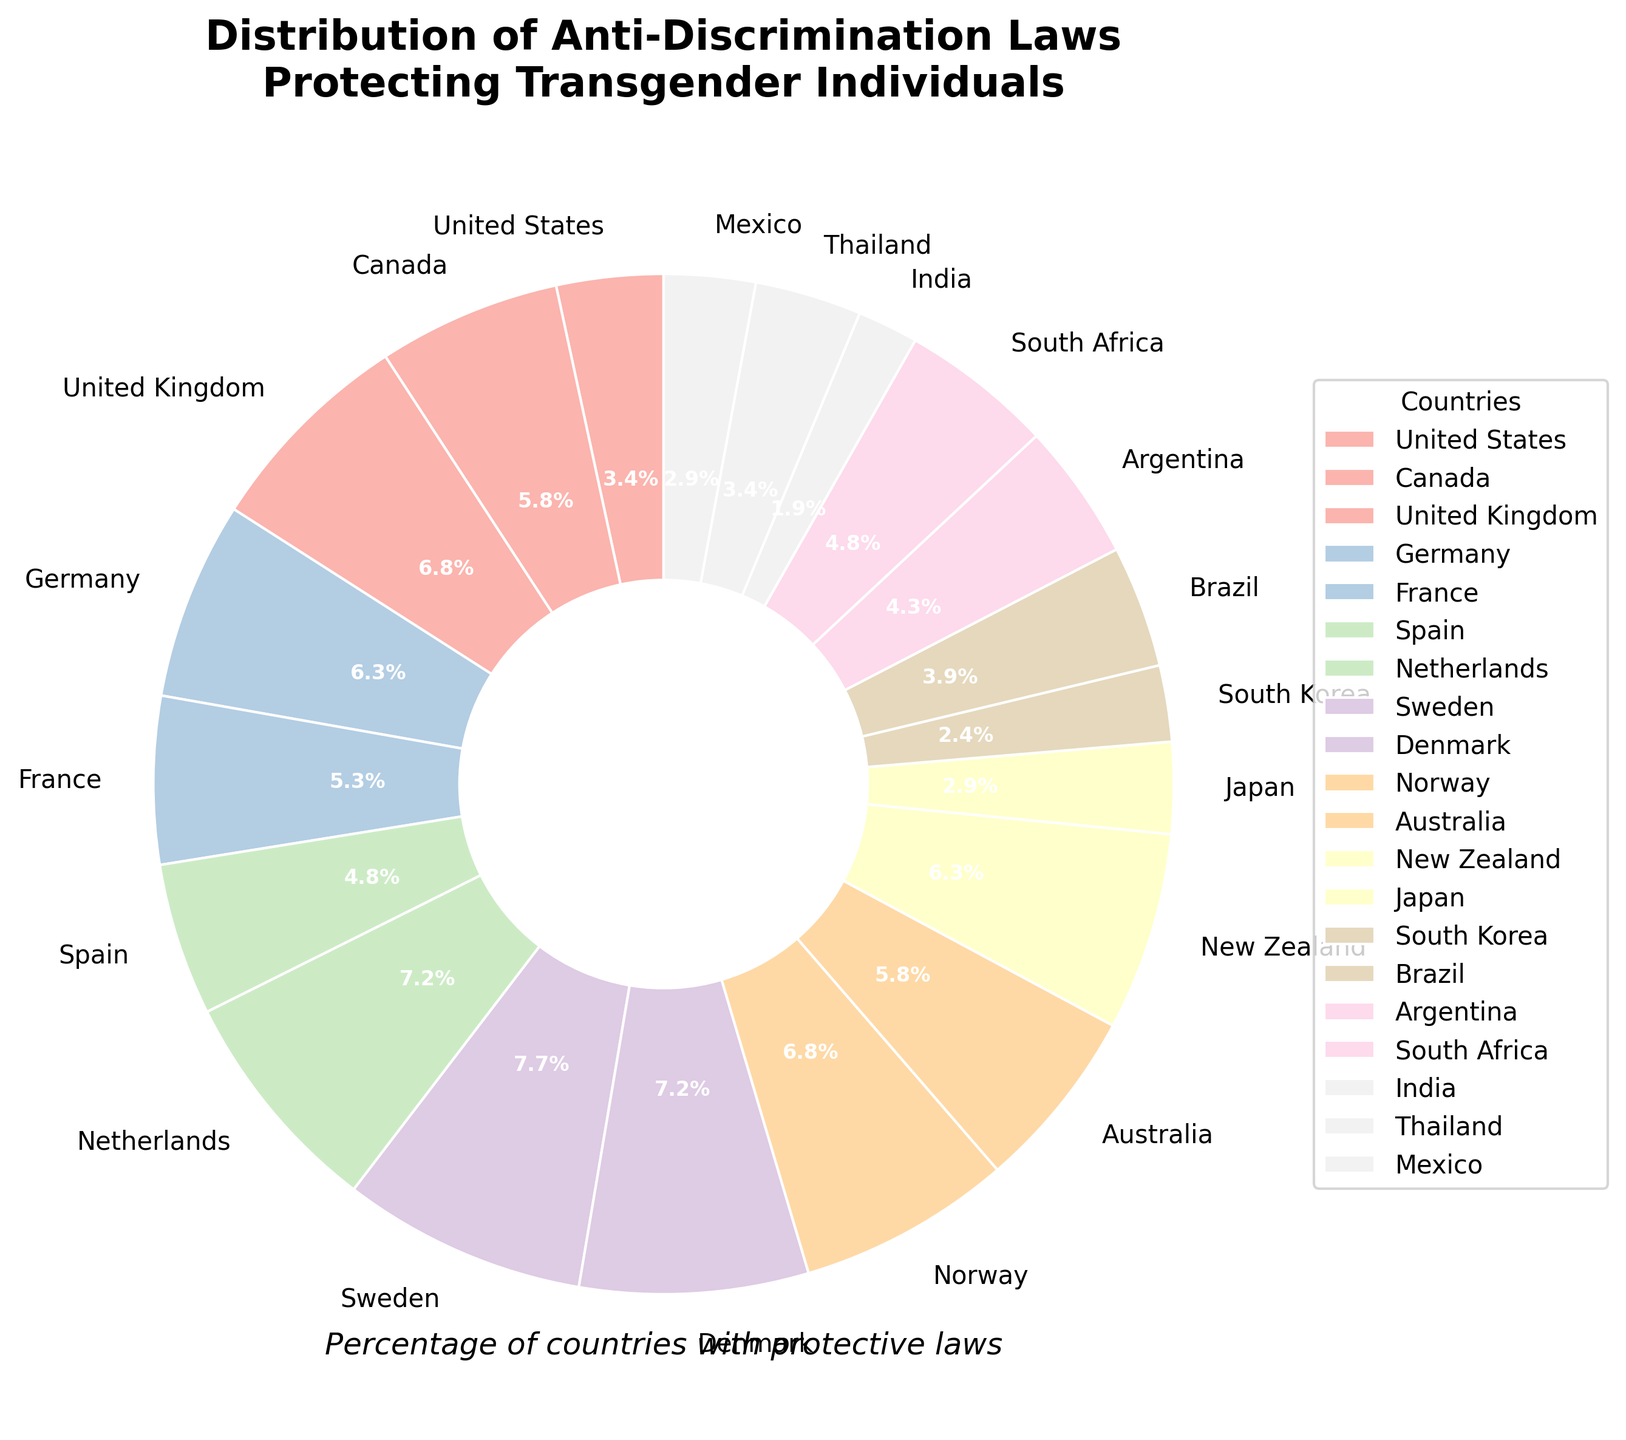Which country has the highest percentage of anti-discrimination laws protecting transgender individuals? The highest percentage can be found by looking at the largest wedge in the pie chart. The largest wedge corresponds to Sweden, labeled with 80%.
Answer: Sweden Which country has the lowest percentage of anti-discrimination laws? The smallest wedge in the pie chart represents the country with the lowest percentage. This wedge corresponds to India, labeled with 20%.
Answer: India What is the combined percentage of countries protecting transgender individuals in the United Kingdom, Norway, and the Netherlands? Sum the percentages for the United Kingdom (70%), Norway (70%), and the Netherlands (75%). 70 + 70 + 75 = 215%
Answer: 215% Which countries have a percentage equal to or higher than 70%? Identify all wedges labeled with percentages 70% or higher. These countries are United Kingdom (70%), Norway (70%), Denmark (75%), Netherlands (75%), and Sweden (80%).
Answer: United Kingdom, Norway, Denmark, Netherlands, Sweden How does the percentage in the United States compare to that in Canada? Compare the sizes of the wedges for the United States (35%) and Canada (60%). The wedge for Canada is larger indicating that Canada's percentage is higher.
Answer: Canada's percentage is higher What is the average percentage of anti-discrimination laws among the countries listed in the pie chart? Sum all the percentages and divide by the number of countries. Total sum: 35 + 60 + 70 + 65 + 55 + 50 + 75 + 80 + 75 + 70 + 60 + 65 + 30 + 25 + 40 + 45 + 50 + 20 + 35 + 30 = 1035. Number of countries: 20. Average = 1035 / 20 = 51.75%
Answer: 51.75% Which countries have a percentage between 50% and 60%? Identify the wedges labeled with percentages in the range of 50% and 60%. These countries are France (55%), Spain (50%), Australia (60%), and South Africa (50%).
Answer: France, Spain, Australia, South Africa Is the percentage in Japan higher or lower than that in Mexico? Compare the wedges for Japan (30%) and Mexico (30%). Both are labeled with the same percentage.
Answer: Equal What is the total percentage of the countries with a percentage lower than 30%? Identify countries below 30%, which are South Korea (25%) and India (20%), then sum their percentages. 25 + 20 = 45%
Answer: 45% Which one has a higher percentage: Brazil or Argentina? Compare the wedges for Brazil (40%) and Argentina (45%). The wedge for Argentina is larger indicating its percentage is higher.
Answer: Argentina 